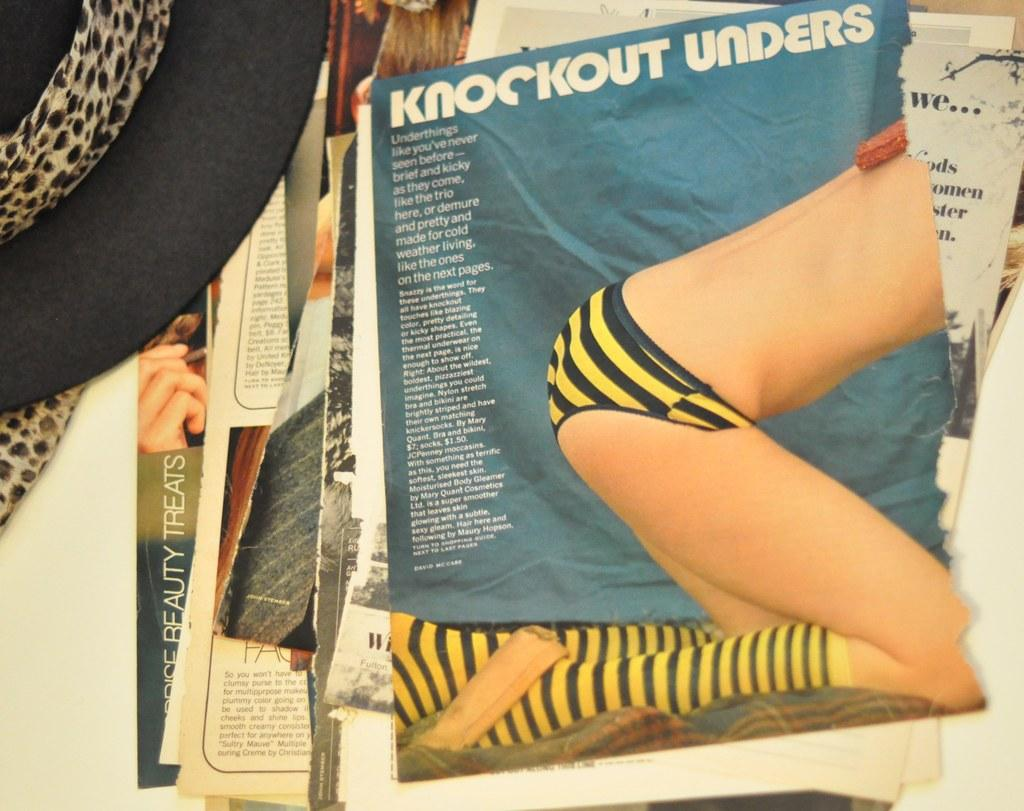What is the main subject in the center of the image? There are papers with text in the center of the image. What type of accessory is located on the left side of the image? There is a black hat on the left side of the image. What type of rake is being used to create the text on the papers in the image? There is no rake present in the image, and the text on the papers is not created using a rake. What type of canvas is the black hat resting on in the image? There is no canvas present in the image, and the black hat is resting on the surface of the image, not on a canvas. 